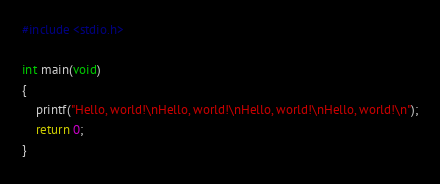Convert code to text. <code><loc_0><loc_0><loc_500><loc_500><_C_>#include <stdio.h>

int main(void)
{
    printf("Hello, world!\nHello, world!\nHello, world!\nHello, world!\n");
    return 0;
}
</code> 